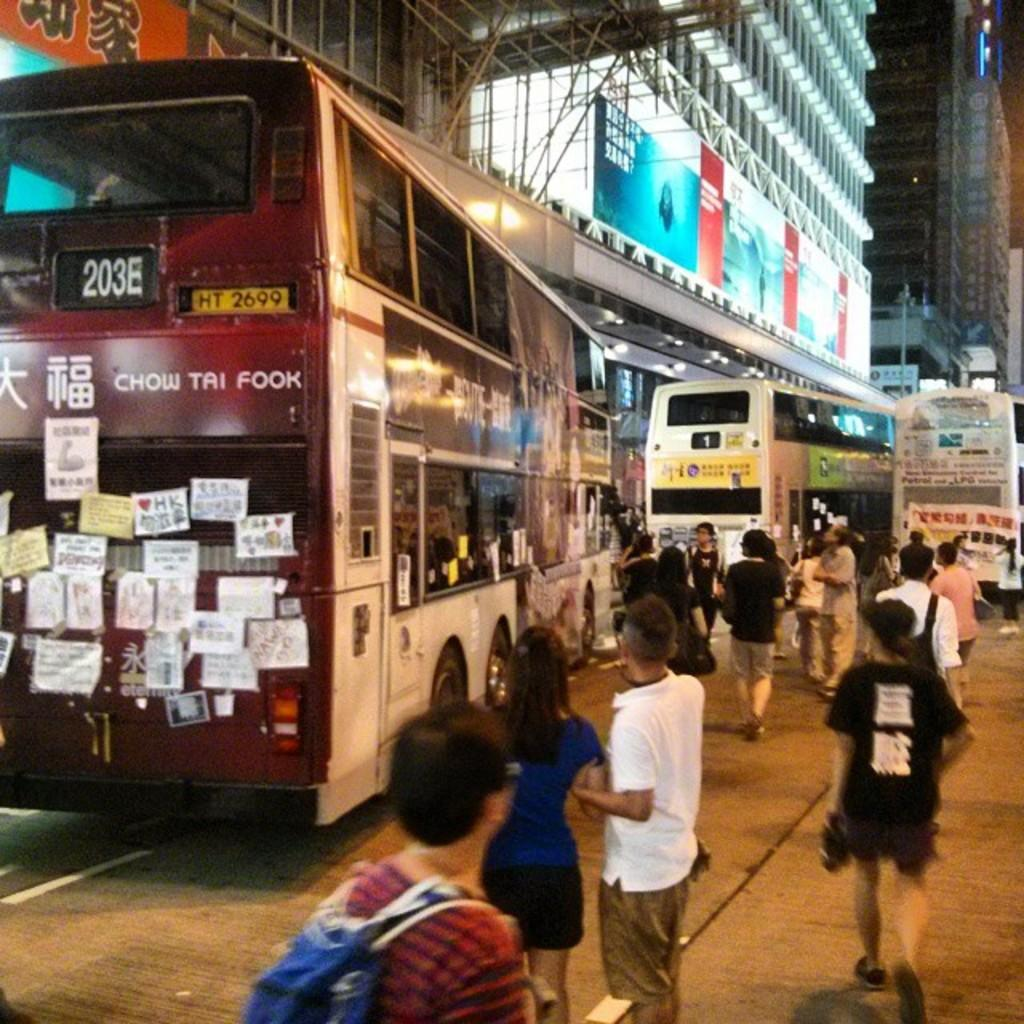<image>
Present a compact description of the photo's key features. The 203E bus is pulling away from the corner onto the street. 